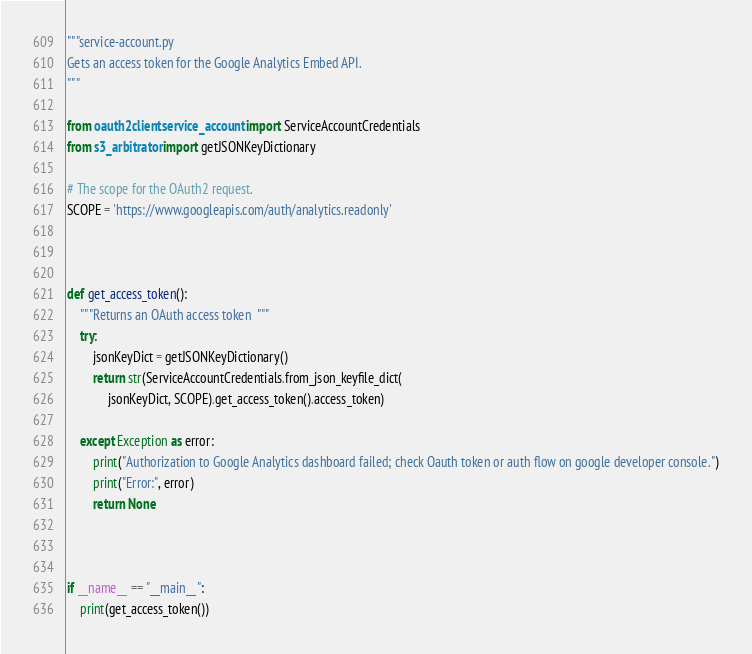<code> <loc_0><loc_0><loc_500><loc_500><_Python_>"""service-account.py
Gets an access token for the Google Analytics Embed API.
"""

from oauth2client.service_account import ServiceAccountCredentials
from s3_arbitrator import getJSONKeyDictionary

# The scope for the OAuth2 request.
SCOPE = 'https://www.googleapis.com/auth/analytics.readonly'



def get_access_token():
    """Returns an OAuth access token  """
    try:
        jsonKeyDict = getJSONKeyDictionary()
        return str(ServiceAccountCredentials.from_json_keyfile_dict(
             jsonKeyDict, SCOPE).get_access_token().access_token)

    except Exception as error:
        print("Authorization to Google Analytics dashboard failed; check Oauth token or auth flow on google developer console.")
        print("Error:", error)
        return None



if __name__ == "__main__":
    print(get_access_token())
</code> 